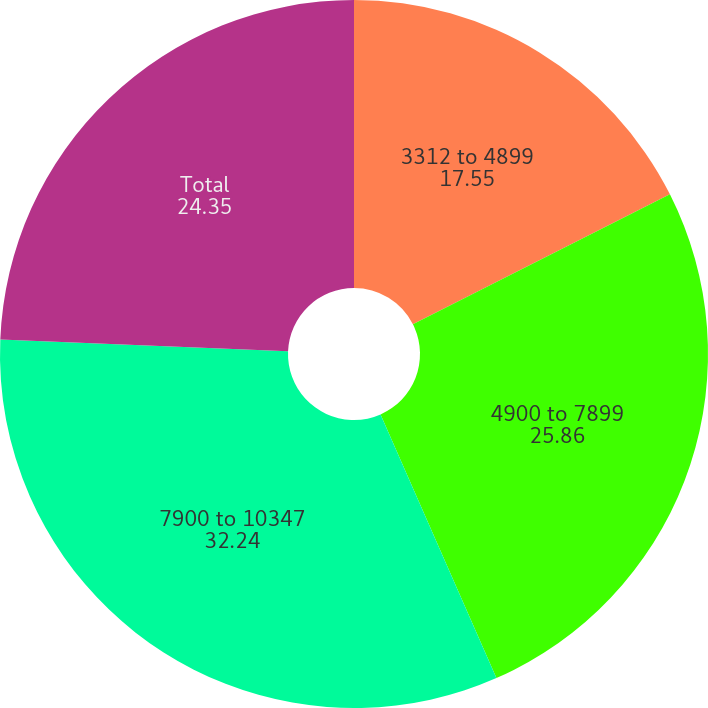Convert chart to OTSL. <chart><loc_0><loc_0><loc_500><loc_500><pie_chart><fcel>3312 to 4899<fcel>4900 to 7899<fcel>7900 to 10347<fcel>Total<nl><fcel>17.55%<fcel>25.86%<fcel>32.24%<fcel>24.35%<nl></chart> 